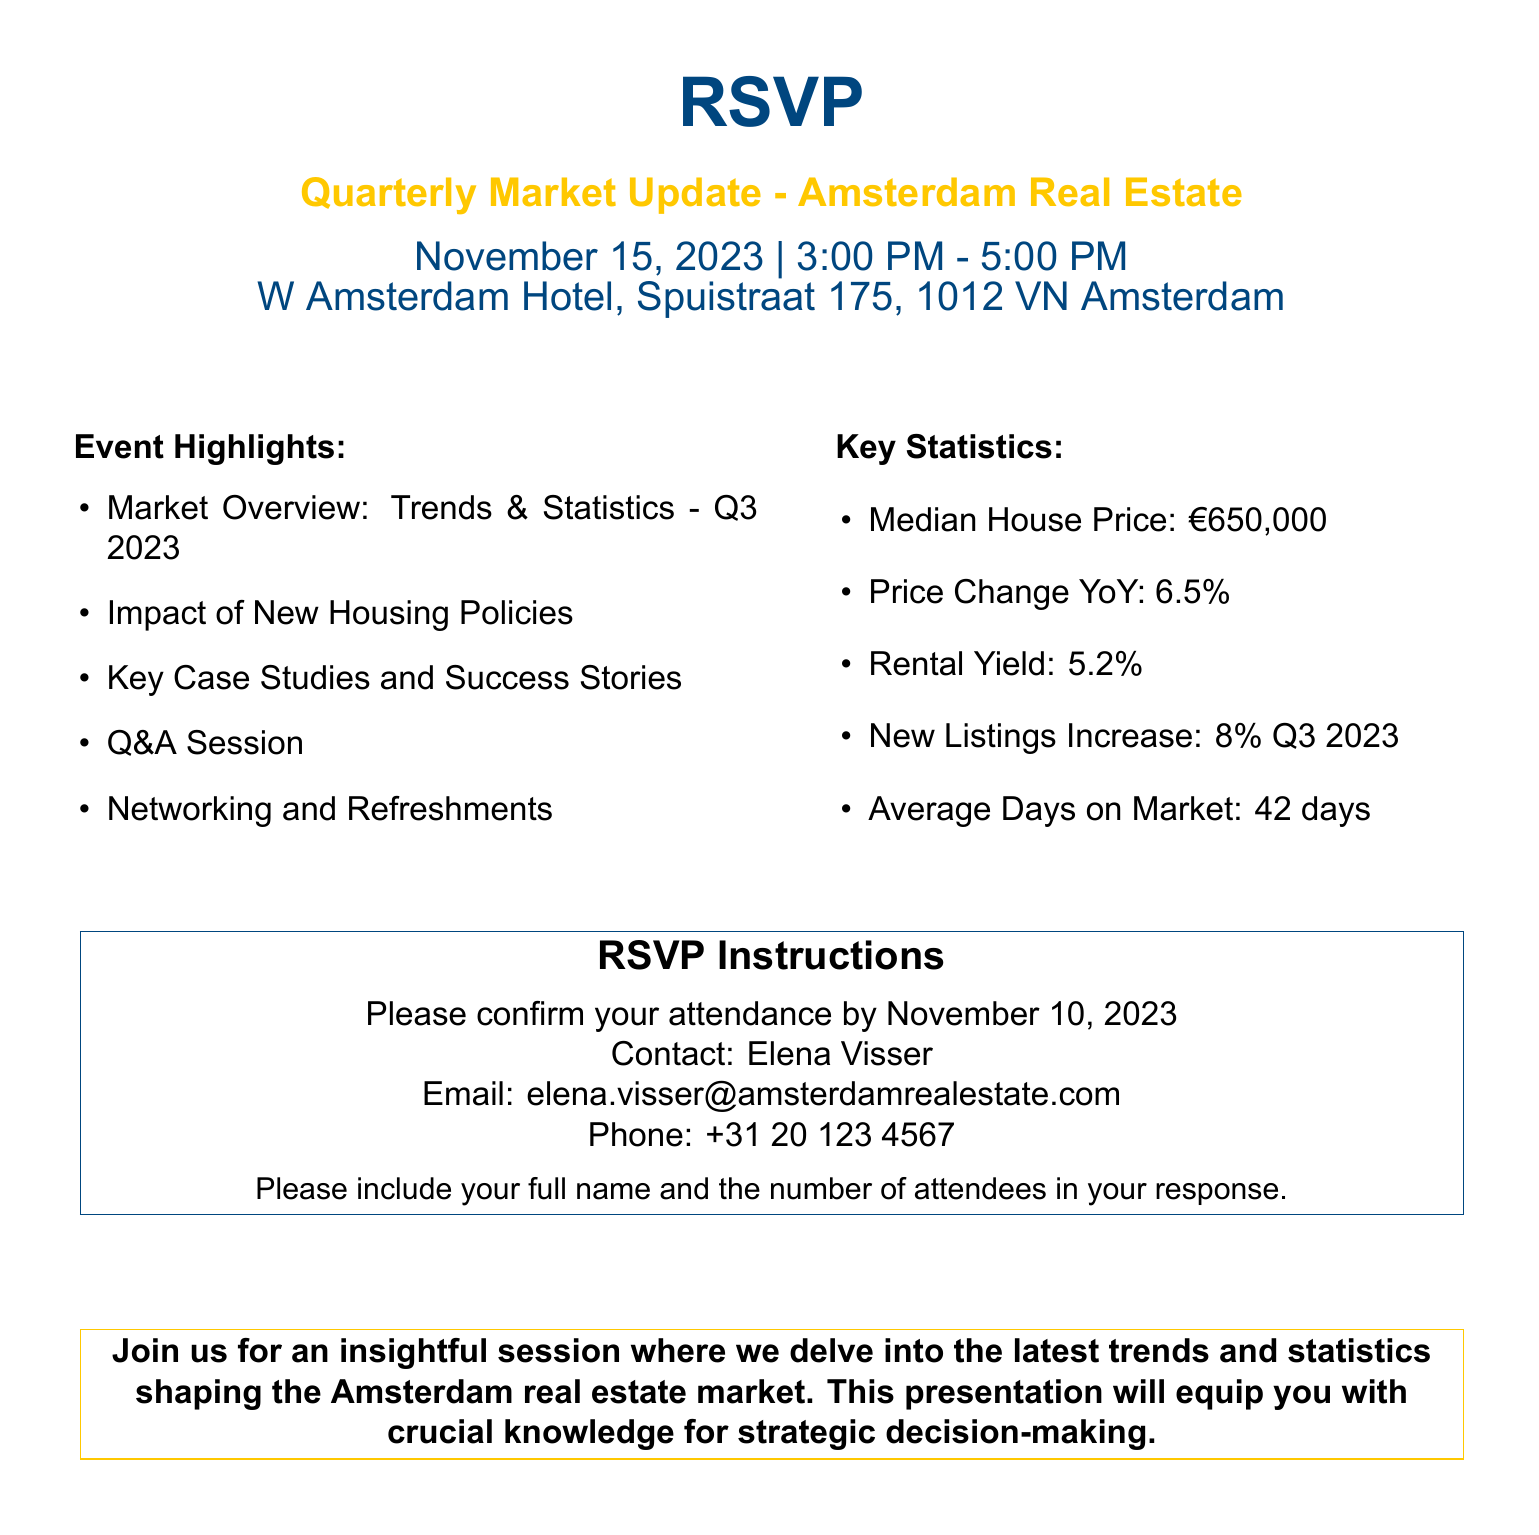What is the date of the event? The event is scheduled for November 15, 2023.
Answer: November 15, 2023 What is the location of the presentation? The presentation will be held at W Amsterdam Hotel, Spuistraat 175, 1012 VN Amsterdam.
Answer: W Amsterdam Hotel, Spuistraat 175, 1012 VN Amsterdam What is the median house price according to the update? The median house price is stated as €650,000.
Answer: €650,000 What is the email contact for RSVP? The document provides Elena Visser's email as elena.visser@amsterdamrealestate.com.
Answer: elena.visser@amsterdamrealestate.com How many attendees should be included in the RSVP? The RSVP requires you to include the number of attendees in your response.
Answer: Number of attendees What is the price change year over year (YoY)? The price change YoY is mentioned as 6.5%.
Answer: 6.5% What is the time duration of the event? The event runs from 3:00 PM to 5:00 PM, indicating a 2-hour duration.
Answer: 2 hours What is stated about the New Listings Increase? The document mentions an 8% increase in new listings for Q3 2023.
Answer: 8% Q3 2023 What is the RSVP confirmation deadline? Attendees must confirm their attendance by November 10, 2023.
Answer: November 10, 2023 